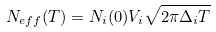Convert formula to latex. <formula><loc_0><loc_0><loc_500><loc_500>N _ { e f f } ( T ) = N _ { i } ( 0 ) V _ { i } \sqrt { 2 \pi \Delta _ { i } T }</formula> 